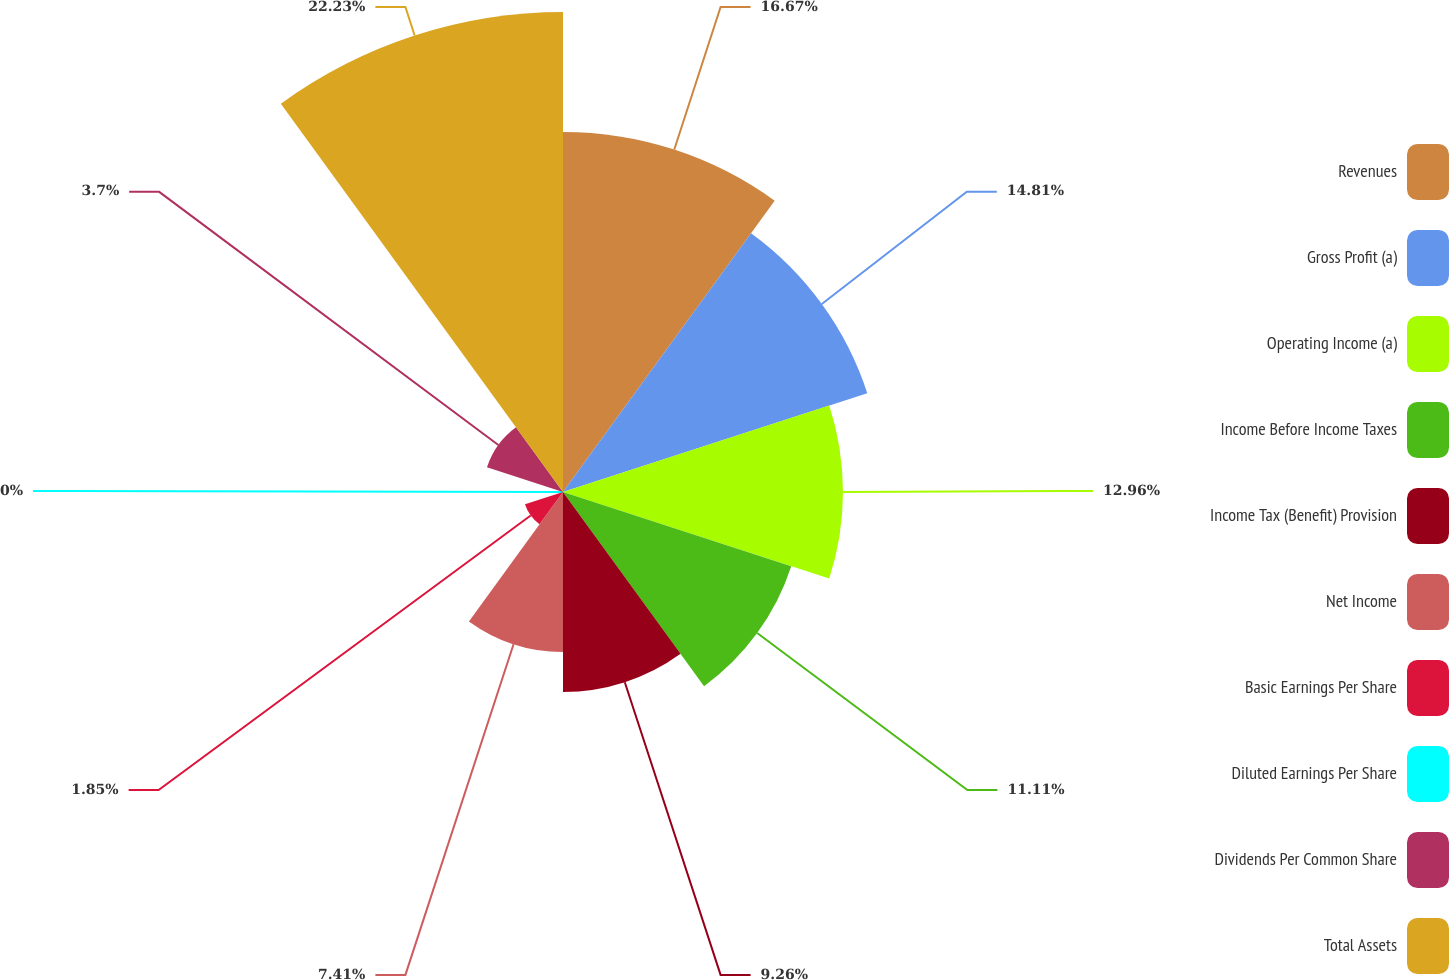Convert chart to OTSL. <chart><loc_0><loc_0><loc_500><loc_500><pie_chart><fcel>Revenues<fcel>Gross Profit (a)<fcel>Operating Income (a)<fcel>Income Before Income Taxes<fcel>Income Tax (Benefit) Provision<fcel>Net Income<fcel>Basic Earnings Per Share<fcel>Diluted Earnings Per Share<fcel>Dividends Per Common Share<fcel>Total Assets<nl><fcel>16.67%<fcel>14.81%<fcel>12.96%<fcel>11.11%<fcel>9.26%<fcel>7.41%<fcel>1.85%<fcel>0.0%<fcel>3.7%<fcel>22.22%<nl></chart> 